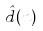<formula> <loc_0><loc_0><loc_500><loc_500>\hat { d } ( n )</formula> 